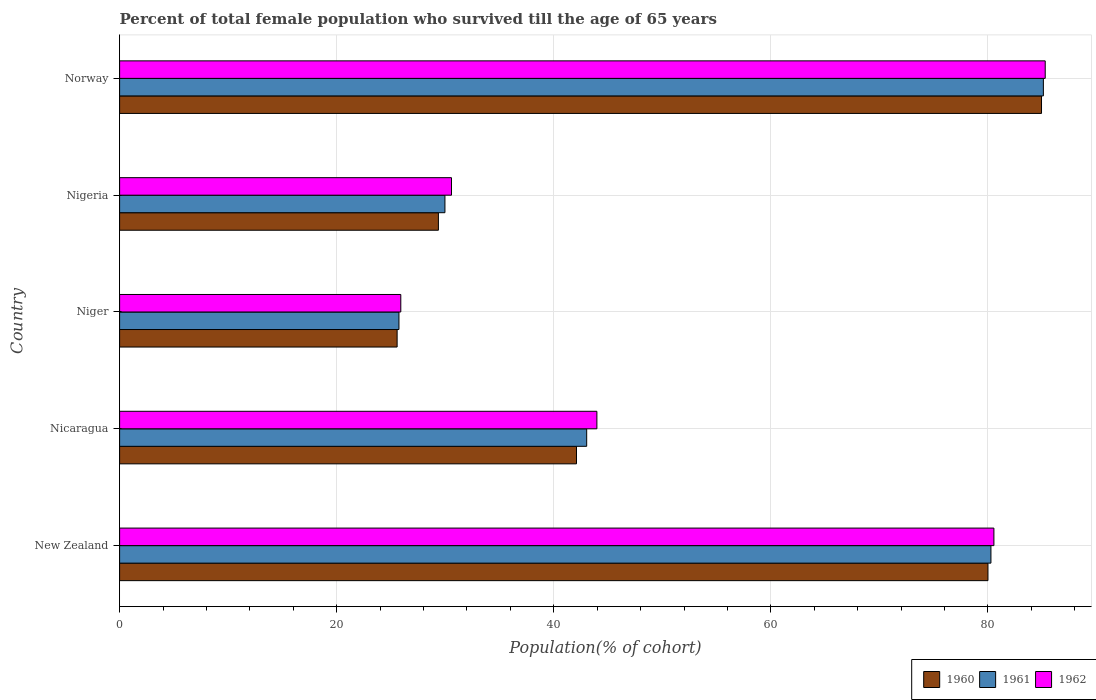How many different coloured bars are there?
Make the answer very short. 3. How many groups of bars are there?
Your answer should be compact. 5. Are the number of bars per tick equal to the number of legend labels?
Give a very brief answer. Yes. What is the label of the 4th group of bars from the top?
Give a very brief answer. Nicaragua. In how many cases, is the number of bars for a given country not equal to the number of legend labels?
Your response must be concise. 0. What is the percentage of total female population who survived till the age of 65 years in 1962 in New Zealand?
Keep it short and to the point. 80.55. Across all countries, what is the maximum percentage of total female population who survived till the age of 65 years in 1962?
Your answer should be compact. 85.28. Across all countries, what is the minimum percentage of total female population who survived till the age of 65 years in 1960?
Offer a very short reply. 25.57. In which country was the percentage of total female population who survived till the age of 65 years in 1961 minimum?
Give a very brief answer. Niger. What is the total percentage of total female population who survived till the age of 65 years in 1962 in the graph?
Make the answer very short. 266.28. What is the difference between the percentage of total female population who survived till the age of 65 years in 1960 in Niger and that in Nigeria?
Offer a terse response. -3.8. What is the difference between the percentage of total female population who survived till the age of 65 years in 1961 in Nicaragua and the percentage of total female population who survived till the age of 65 years in 1960 in Niger?
Your answer should be very brief. 17.46. What is the average percentage of total female population who survived till the age of 65 years in 1962 per country?
Keep it short and to the point. 53.26. What is the difference between the percentage of total female population who survived till the age of 65 years in 1962 and percentage of total female population who survived till the age of 65 years in 1961 in New Zealand?
Make the answer very short. 0.27. What is the ratio of the percentage of total female population who survived till the age of 65 years in 1960 in Nigeria to that in Norway?
Keep it short and to the point. 0.35. Is the percentage of total female population who survived till the age of 65 years in 1960 in New Zealand less than that in Nigeria?
Make the answer very short. No. What is the difference between the highest and the second highest percentage of total female population who survived till the age of 65 years in 1960?
Provide a succinct answer. 4.93. What is the difference between the highest and the lowest percentage of total female population who survived till the age of 65 years in 1961?
Ensure brevity in your answer.  59.37. In how many countries, is the percentage of total female population who survived till the age of 65 years in 1962 greater than the average percentage of total female population who survived till the age of 65 years in 1962 taken over all countries?
Offer a terse response. 2. Is the sum of the percentage of total female population who survived till the age of 65 years in 1962 in New Zealand and Niger greater than the maximum percentage of total female population who survived till the age of 65 years in 1961 across all countries?
Make the answer very short. Yes. What does the 2nd bar from the top in New Zealand represents?
Offer a terse response. 1961. What does the 2nd bar from the bottom in Nicaragua represents?
Give a very brief answer. 1961. How many bars are there?
Your answer should be compact. 15. How many legend labels are there?
Keep it short and to the point. 3. How are the legend labels stacked?
Give a very brief answer. Horizontal. What is the title of the graph?
Ensure brevity in your answer.  Percent of total female population who survived till the age of 65 years. Does "2008" appear as one of the legend labels in the graph?
Make the answer very short. No. What is the label or title of the X-axis?
Provide a succinct answer. Population(% of cohort). What is the label or title of the Y-axis?
Offer a terse response. Country. What is the Population(% of cohort) in 1960 in New Zealand?
Your answer should be compact. 80. What is the Population(% of cohort) of 1961 in New Zealand?
Ensure brevity in your answer.  80.28. What is the Population(% of cohort) of 1962 in New Zealand?
Provide a succinct answer. 80.55. What is the Population(% of cohort) in 1960 in Nicaragua?
Keep it short and to the point. 42.09. What is the Population(% of cohort) of 1961 in Nicaragua?
Make the answer very short. 43.03. What is the Population(% of cohort) of 1962 in Nicaragua?
Provide a succinct answer. 43.97. What is the Population(% of cohort) in 1960 in Niger?
Your answer should be very brief. 25.57. What is the Population(% of cohort) of 1961 in Niger?
Your response must be concise. 25.74. What is the Population(% of cohort) in 1962 in Niger?
Provide a succinct answer. 25.91. What is the Population(% of cohort) in 1960 in Nigeria?
Give a very brief answer. 29.37. What is the Population(% of cohort) in 1961 in Nigeria?
Offer a terse response. 29.97. What is the Population(% of cohort) of 1962 in Nigeria?
Offer a very short reply. 30.58. What is the Population(% of cohort) of 1960 in Norway?
Provide a short and direct response. 84.94. What is the Population(% of cohort) of 1961 in Norway?
Make the answer very short. 85.11. What is the Population(% of cohort) of 1962 in Norway?
Offer a very short reply. 85.28. Across all countries, what is the maximum Population(% of cohort) in 1960?
Provide a succinct answer. 84.94. Across all countries, what is the maximum Population(% of cohort) in 1961?
Your answer should be compact. 85.11. Across all countries, what is the maximum Population(% of cohort) of 1962?
Offer a very short reply. 85.28. Across all countries, what is the minimum Population(% of cohort) of 1960?
Your answer should be very brief. 25.57. Across all countries, what is the minimum Population(% of cohort) of 1961?
Provide a succinct answer. 25.74. Across all countries, what is the minimum Population(% of cohort) of 1962?
Your answer should be very brief. 25.91. What is the total Population(% of cohort) in 1960 in the graph?
Provide a short and direct response. 261.97. What is the total Population(% of cohort) in 1961 in the graph?
Your response must be concise. 264.12. What is the total Population(% of cohort) in 1962 in the graph?
Ensure brevity in your answer.  266.28. What is the difference between the Population(% of cohort) in 1960 in New Zealand and that in Nicaragua?
Provide a short and direct response. 37.91. What is the difference between the Population(% of cohort) of 1961 in New Zealand and that in Nicaragua?
Provide a short and direct response. 37.24. What is the difference between the Population(% of cohort) in 1962 in New Zealand and that in Nicaragua?
Ensure brevity in your answer.  36.58. What is the difference between the Population(% of cohort) in 1960 in New Zealand and that in Niger?
Offer a very short reply. 54.43. What is the difference between the Population(% of cohort) in 1961 in New Zealand and that in Niger?
Your answer should be compact. 54.54. What is the difference between the Population(% of cohort) in 1962 in New Zealand and that in Niger?
Provide a succinct answer. 54.64. What is the difference between the Population(% of cohort) of 1960 in New Zealand and that in Nigeria?
Provide a short and direct response. 50.63. What is the difference between the Population(% of cohort) of 1961 in New Zealand and that in Nigeria?
Ensure brevity in your answer.  50.3. What is the difference between the Population(% of cohort) in 1962 in New Zealand and that in Nigeria?
Provide a succinct answer. 49.97. What is the difference between the Population(% of cohort) in 1960 in New Zealand and that in Norway?
Ensure brevity in your answer.  -4.93. What is the difference between the Population(% of cohort) in 1961 in New Zealand and that in Norway?
Give a very brief answer. -4.83. What is the difference between the Population(% of cohort) in 1962 in New Zealand and that in Norway?
Offer a very short reply. -4.73. What is the difference between the Population(% of cohort) of 1960 in Nicaragua and that in Niger?
Offer a very short reply. 16.53. What is the difference between the Population(% of cohort) of 1961 in Nicaragua and that in Niger?
Provide a succinct answer. 17.3. What is the difference between the Population(% of cohort) in 1962 in Nicaragua and that in Niger?
Keep it short and to the point. 18.07. What is the difference between the Population(% of cohort) of 1960 in Nicaragua and that in Nigeria?
Make the answer very short. 12.72. What is the difference between the Population(% of cohort) in 1961 in Nicaragua and that in Nigeria?
Provide a succinct answer. 13.06. What is the difference between the Population(% of cohort) in 1962 in Nicaragua and that in Nigeria?
Your answer should be very brief. 13.4. What is the difference between the Population(% of cohort) in 1960 in Nicaragua and that in Norway?
Make the answer very short. -42.84. What is the difference between the Population(% of cohort) of 1961 in Nicaragua and that in Norway?
Your answer should be very brief. -42.07. What is the difference between the Population(% of cohort) in 1962 in Nicaragua and that in Norway?
Your response must be concise. -41.3. What is the difference between the Population(% of cohort) of 1960 in Niger and that in Nigeria?
Offer a terse response. -3.8. What is the difference between the Population(% of cohort) in 1961 in Niger and that in Nigeria?
Your answer should be compact. -4.24. What is the difference between the Population(% of cohort) of 1962 in Niger and that in Nigeria?
Offer a terse response. -4.67. What is the difference between the Population(% of cohort) of 1960 in Niger and that in Norway?
Provide a short and direct response. -59.37. What is the difference between the Population(% of cohort) of 1961 in Niger and that in Norway?
Your answer should be compact. -59.37. What is the difference between the Population(% of cohort) in 1962 in Niger and that in Norway?
Provide a succinct answer. -59.37. What is the difference between the Population(% of cohort) of 1960 in Nigeria and that in Norway?
Provide a short and direct response. -55.57. What is the difference between the Population(% of cohort) in 1961 in Nigeria and that in Norway?
Offer a terse response. -55.13. What is the difference between the Population(% of cohort) of 1962 in Nigeria and that in Norway?
Offer a very short reply. -54.7. What is the difference between the Population(% of cohort) in 1960 in New Zealand and the Population(% of cohort) in 1961 in Nicaragua?
Your response must be concise. 36.97. What is the difference between the Population(% of cohort) of 1960 in New Zealand and the Population(% of cohort) of 1962 in Nicaragua?
Offer a very short reply. 36.03. What is the difference between the Population(% of cohort) of 1961 in New Zealand and the Population(% of cohort) of 1962 in Nicaragua?
Provide a short and direct response. 36.3. What is the difference between the Population(% of cohort) in 1960 in New Zealand and the Population(% of cohort) in 1961 in Niger?
Your response must be concise. 54.27. What is the difference between the Population(% of cohort) of 1960 in New Zealand and the Population(% of cohort) of 1962 in Niger?
Keep it short and to the point. 54.1. What is the difference between the Population(% of cohort) in 1961 in New Zealand and the Population(% of cohort) in 1962 in Niger?
Provide a succinct answer. 54.37. What is the difference between the Population(% of cohort) in 1960 in New Zealand and the Population(% of cohort) in 1961 in Nigeria?
Offer a very short reply. 50.03. What is the difference between the Population(% of cohort) in 1960 in New Zealand and the Population(% of cohort) in 1962 in Nigeria?
Provide a succinct answer. 49.43. What is the difference between the Population(% of cohort) in 1961 in New Zealand and the Population(% of cohort) in 1962 in Nigeria?
Your response must be concise. 49.7. What is the difference between the Population(% of cohort) in 1960 in New Zealand and the Population(% of cohort) in 1961 in Norway?
Ensure brevity in your answer.  -5.1. What is the difference between the Population(% of cohort) of 1960 in New Zealand and the Population(% of cohort) of 1962 in Norway?
Your response must be concise. -5.27. What is the difference between the Population(% of cohort) of 1961 in New Zealand and the Population(% of cohort) of 1962 in Norway?
Your answer should be compact. -5. What is the difference between the Population(% of cohort) in 1960 in Nicaragua and the Population(% of cohort) in 1961 in Niger?
Keep it short and to the point. 16.36. What is the difference between the Population(% of cohort) of 1960 in Nicaragua and the Population(% of cohort) of 1962 in Niger?
Offer a very short reply. 16.19. What is the difference between the Population(% of cohort) in 1961 in Nicaragua and the Population(% of cohort) in 1962 in Niger?
Offer a very short reply. 17.13. What is the difference between the Population(% of cohort) of 1960 in Nicaragua and the Population(% of cohort) of 1961 in Nigeria?
Offer a terse response. 12.12. What is the difference between the Population(% of cohort) of 1960 in Nicaragua and the Population(% of cohort) of 1962 in Nigeria?
Provide a short and direct response. 11.52. What is the difference between the Population(% of cohort) of 1961 in Nicaragua and the Population(% of cohort) of 1962 in Nigeria?
Your response must be concise. 12.46. What is the difference between the Population(% of cohort) of 1960 in Nicaragua and the Population(% of cohort) of 1961 in Norway?
Your response must be concise. -43.01. What is the difference between the Population(% of cohort) of 1960 in Nicaragua and the Population(% of cohort) of 1962 in Norway?
Provide a succinct answer. -43.18. What is the difference between the Population(% of cohort) of 1961 in Nicaragua and the Population(% of cohort) of 1962 in Norway?
Keep it short and to the point. -42.24. What is the difference between the Population(% of cohort) of 1960 in Niger and the Population(% of cohort) of 1961 in Nigeria?
Keep it short and to the point. -4.41. What is the difference between the Population(% of cohort) of 1960 in Niger and the Population(% of cohort) of 1962 in Nigeria?
Your answer should be very brief. -5.01. What is the difference between the Population(% of cohort) in 1961 in Niger and the Population(% of cohort) in 1962 in Nigeria?
Provide a succinct answer. -4.84. What is the difference between the Population(% of cohort) of 1960 in Niger and the Population(% of cohort) of 1961 in Norway?
Provide a short and direct response. -59.54. What is the difference between the Population(% of cohort) of 1960 in Niger and the Population(% of cohort) of 1962 in Norway?
Keep it short and to the point. -59.71. What is the difference between the Population(% of cohort) of 1961 in Niger and the Population(% of cohort) of 1962 in Norway?
Keep it short and to the point. -59.54. What is the difference between the Population(% of cohort) of 1960 in Nigeria and the Population(% of cohort) of 1961 in Norway?
Give a very brief answer. -55.73. What is the difference between the Population(% of cohort) of 1960 in Nigeria and the Population(% of cohort) of 1962 in Norway?
Give a very brief answer. -55.9. What is the difference between the Population(% of cohort) in 1961 in Nigeria and the Population(% of cohort) in 1962 in Norway?
Make the answer very short. -55.3. What is the average Population(% of cohort) of 1960 per country?
Offer a very short reply. 52.39. What is the average Population(% of cohort) in 1961 per country?
Your response must be concise. 52.82. What is the average Population(% of cohort) in 1962 per country?
Give a very brief answer. 53.26. What is the difference between the Population(% of cohort) of 1960 and Population(% of cohort) of 1961 in New Zealand?
Your answer should be compact. -0.27. What is the difference between the Population(% of cohort) of 1960 and Population(% of cohort) of 1962 in New Zealand?
Make the answer very short. -0.55. What is the difference between the Population(% of cohort) of 1961 and Population(% of cohort) of 1962 in New Zealand?
Your response must be concise. -0.27. What is the difference between the Population(% of cohort) of 1960 and Population(% of cohort) of 1961 in Nicaragua?
Give a very brief answer. -0.94. What is the difference between the Population(% of cohort) in 1960 and Population(% of cohort) in 1962 in Nicaragua?
Make the answer very short. -1.88. What is the difference between the Population(% of cohort) in 1961 and Population(% of cohort) in 1962 in Nicaragua?
Offer a terse response. -0.94. What is the difference between the Population(% of cohort) in 1960 and Population(% of cohort) in 1961 in Niger?
Your answer should be very brief. -0.17. What is the difference between the Population(% of cohort) in 1960 and Population(% of cohort) in 1962 in Niger?
Offer a terse response. -0.34. What is the difference between the Population(% of cohort) in 1961 and Population(% of cohort) in 1962 in Niger?
Offer a terse response. -0.17. What is the difference between the Population(% of cohort) of 1960 and Population(% of cohort) of 1961 in Nigeria?
Make the answer very short. -0.6. What is the difference between the Population(% of cohort) of 1960 and Population(% of cohort) of 1962 in Nigeria?
Your answer should be compact. -1.21. What is the difference between the Population(% of cohort) of 1961 and Population(% of cohort) of 1962 in Nigeria?
Provide a short and direct response. -0.6. What is the difference between the Population(% of cohort) in 1960 and Population(% of cohort) in 1961 in Norway?
Provide a succinct answer. -0.17. What is the difference between the Population(% of cohort) in 1960 and Population(% of cohort) in 1962 in Norway?
Give a very brief answer. -0.34. What is the difference between the Population(% of cohort) of 1961 and Population(% of cohort) of 1962 in Norway?
Offer a very short reply. -0.17. What is the ratio of the Population(% of cohort) of 1960 in New Zealand to that in Nicaragua?
Your answer should be very brief. 1.9. What is the ratio of the Population(% of cohort) of 1961 in New Zealand to that in Nicaragua?
Keep it short and to the point. 1.87. What is the ratio of the Population(% of cohort) in 1962 in New Zealand to that in Nicaragua?
Ensure brevity in your answer.  1.83. What is the ratio of the Population(% of cohort) in 1960 in New Zealand to that in Niger?
Ensure brevity in your answer.  3.13. What is the ratio of the Population(% of cohort) in 1961 in New Zealand to that in Niger?
Offer a very short reply. 3.12. What is the ratio of the Population(% of cohort) of 1962 in New Zealand to that in Niger?
Your answer should be very brief. 3.11. What is the ratio of the Population(% of cohort) of 1960 in New Zealand to that in Nigeria?
Keep it short and to the point. 2.72. What is the ratio of the Population(% of cohort) of 1961 in New Zealand to that in Nigeria?
Provide a succinct answer. 2.68. What is the ratio of the Population(% of cohort) of 1962 in New Zealand to that in Nigeria?
Your response must be concise. 2.63. What is the ratio of the Population(% of cohort) in 1960 in New Zealand to that in Norway?
Provide a short and direct response. 0.94. What is the ratio of the Population(% of cohort) in 1961 in New Zealand to that in Norway?
Keep it short and to the point. 0.94. What is the ratio of the Population(% of cohort) of 1962 in New Zealand to that in Norway?
Ensure brevity in your answer.  0.94. What is the ratio of the Population(% of cohort) of 1960 in Nicaragua to that in Niger?
Your answer should be very brief. 1.65. What is the ratio of the Population(% of cohort) in 1961 in Nicaragua to that in Niger?
Give a very brief answer. 1.67. What is the ratio of the Population(% of cohort) in 1962 in Nicaragua to that in Niger?
Make the answer very short. 1.7. What is the ratio of the Population(% of cohort) in 1960 in Nicaragua to that in Nigeria?
Ensure brevity in your answer.  1.43. What is the ratio of the Population(% of cohort) of 1961 in Nicaragua to that in Nigeria?
Give a very brief answer. 1.44. What is the ratio of the Population(% of cohort) of 1962 in Nicaragua to that in Nigeria?
Your answer should be compact. 1.44. What is the ratio of the Population(% of cohort) in 1960 in Nicaragua to that in Norway?
Your response must be concise. 0.5. What is the ratio of the Population(% of cohort) in 1961 in Nicaragua to that in Norway?
Your response must be concise. 0.51. What is the ratio of the Population(% of cohort) in 1962 in Nicaragua to that in Norway?
Provide a short and direct response. 0.52. What is the ratio of the Population(% of cohort) in 1960 in Niger to that in Nigeria?
Make the answer very short. 0.87. What is the ratio of the Population(% of cohort) of 1961 in Niger to that in Nigeria?
Provide a succinct answer. 0.86. What is the ratio of the Population(% of cohort) of 1962 in Niger to that in Nigeria?
Keep it short and to the point. 0.85. What is the ratio of the Population(% of cohort) of 1960 in Niger to that in Norway?
Give a very brief answer. 0.3. What is the ratio of the Population(% of cohort) of 1961 in Niger to that in Norway?
Make the answer very short. 0.3. What is the ratio of the Population(% of cohort) in 1962 in Niger to that in Norway?
Make the answer very short. 0.3. What is the ratio of the Population(% of cohort) of 1960 in Nigeria to that in Norway?
Make the answer very short. 0.35. What is the ratio of the Population(% of cohort) in 1961 in Nigeria to that in Norway?
Make the answer very short. 0.35. What is the ratio of the Population(% of cohort) in 1962 in Nigeria to that in Norway?
Offer a terse response. 0.36. What is the difference between the highest and the second highest Population(% of cohort) of 1960?
Make the answer very short. 4.93. What is the difference between the highest and the second highest Population(% of cohort) in 1961?
Your answer should be very brief. 4.83. What is the difference between the highest and the second highest Population(% of cohort) in 1962?
Provide a succinct answer. 4.73. What is the difference between the highest and the lowest Population(% of cohort) of 1960?
Give a very brief answer. 59.37. What is the difference between the highest and the lowest Population(% of cohort) in 1961?
Provide a succinct answer. 59.37. What is the difference between the highest and the lowest Population(% of cohort) of 1962?
Offer a terse response. 59.37. 